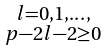<formula> <loc_0><loc_0><loc_500><loc_500>\begin{smallmatrix} l = 0 , 1 , \dots , \\ p - 2 l - 2 \geq 0 \end{smallmatrix}</formula> 